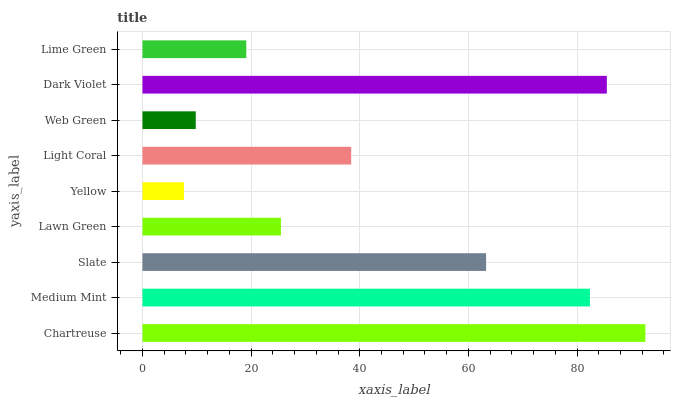Is Yellow the minimum?
Answer yes or no. Yes. Is Chartreuse the maximum?
Answer yes or no. Yes. Is Medium Mint the minimum?
Answer yes or no. No. Is Medium Mint the maximum?
Answer yes or no. No. Is Chartreuse greater than Medium Mint?
Answer yes or no. Yes. Is Medium Mint less than Chartreuse?
Answer yes or no. Yes. Is Medium Mint greater than Chartreuse?
Answer yes or no. No. Is Chartreuse less than Medium Mint?
Answer yes or no. No. Is Light Coral the high median?
Answer yes or no. Yes. Is Light Coral the low median?
Answer yes or no. Yes. Is Chartreuse the high median?
Answer yes or no. No. Is Medium Mint the low median?
Answer yes or no. No. 